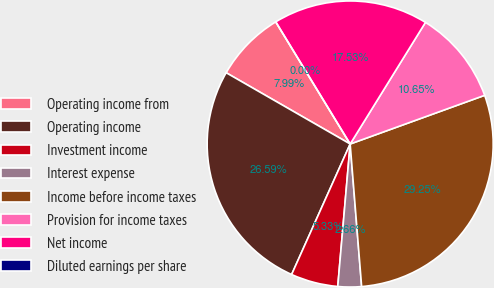Convert chart to OTSL. <chart><loc_0><loc_0><loc_500><loc_500><pie_chart><fcel>Operating income from<fcel>Operating income<fcel>Investment income<fcel>Interest expense<fcel>Income before income taxes<fcel>Provision for income taxes<fcel>Net income<fcel>Diluted earnings per share<nl><fcel>7.99%<fcel>26.59%<fcel>5.33%<fcel>2.66%<fcel>29.25%<fcel>10.65%<fcel>17.53%<fcel>0.0%<nl></chart> 